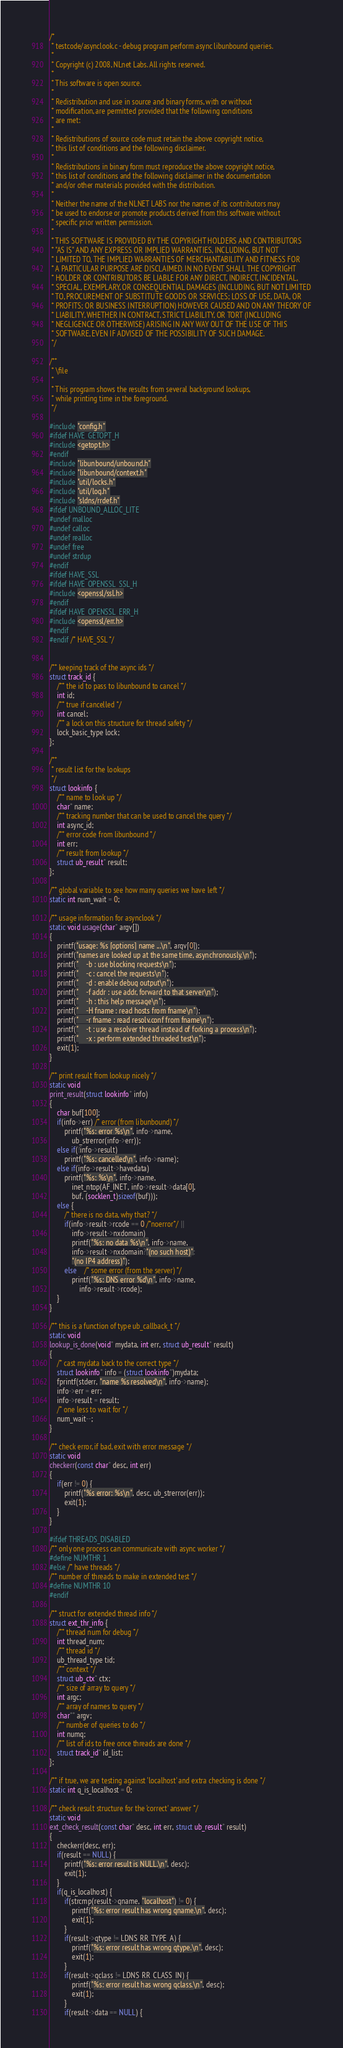<code> <loc_0><loc_0><loc_500><loc_500><_C_>/*
 * testcode/asynclook.c - debug program perform async libunbound queries.
 *
 * Copyright (c) 2008, NLnet Labs. All rights reserved.
 *
 * This software is open source.
 * 
 * Redistribution and use in source and binary forms, with or without
 * modification, are permitted provided that the following conditions
 * are met:
 * 
 * Redistributions of source code must retain the above copyright notice,
 * this list of conditions and the following disclaimer.
 * 
 * Redistributions in binary form must reproduce the above copyright notice,
 * this list of conditions and the following disclaimer in the documentation
 * and/or other materials provided with the distribution.
 * 
 * Neither the name of the NLNET LABS nor the names of its contributors may
 * be used to endorse or promote products derived from this software without
 * specific prior written permission.
 * 
 * THIS SOFTWARE IS PROVIDED BY THE COPYRIGHT HOLDERS AND CONTRIBUTORS
 * "AS IS" AND ANY EXPRESS OR IMPLIED WARRANTIES, INCLUDING, BUT NOT
 * LIMITED TO, THE IMPLIED WARRANTIES OF MERCHANTABILITY AND FITNESS FOR
 * A PARTICULAR PURPOSE ARE DISCLAIMED. IN NO EVENT SHALL THE COPYRIGHT
 * HOLDER OR CONTRIBUTORS BE LIABLE FOR ANY DIRECT, INDIRECT, INCIDENTAL,
 * SPECIAL, EXEMPLARY, OR CONSEQUENTIAL DAMAGES (INCLUDING, BUT NOT LIMITED
 * TO, PROCUREMENT OF SUBSTITUTE GOODS OR SERVICES; LOSS OF USE, DATA, OR
 * PROFITS; OR BUSINESS INTERRUPTION) HOWEVER CAUSED AND ON ANY THEORY OF
 * LIABILITY, WHETHER IN CONTRACT, STRICT LIABILITY, OR TORT (INCLUDING
 * NEGLIGENCE OR OTHERWISE) ARISING IN ANY WAY OUT OF THE USE OF THIS
 * SOFTWARE, EVEN IF ADVISED OF THE POSSIBILITY OF SUCH DAMAGE.
 */

/**
 * \file
 *
 * This program shows the results from several background lookups,
 * while printing time in the foreground.
 */

#include "config.h"
#ifdef HAVE_GETOPT_H
#include <getopt.h>
#endif
#include "libunbound/unbound.h"
#include "libunbound/context.h"
#include "util/locks.h"
#include "util/log.h"
#include "sldns/rrdef.h"
#ifdef UNBOUND_ALLOC_LITE
#undef malloc
#undef calloc
#undef realloc
#undef free
#undef strdup
#endif
#ifdef HAVE_SSL
#ifdef HAVE_OPENSSL_SSL_H
#include <openssl/ssl.h>
#endif
#ifdef HAVE_OPENSSL_ERR_H
#include <openssl/err.h>
#endif
#endif /* HAVE_SSL */


/** keeping track of the async ids */
struct track_id {
	/** the id to pass to libunbound to cancel */
	int id;
	/** true if cancelled */
	int cancel;
	/** a lock on this structure for thread safety */
	lock_basic_type lock;
};

/**
 * result list for the lookups
 */
struct lookinfo {
	/** name to look up */
	char* name;
	/** tracking number that can be used to cancel the query */
	int async_id;
	/** error code from libunbound */
	int err;
	/** result from lookup */
	struct ub_result* result;
};

/** global variable to see how many queries we have left */
static int num_wait = 0;

/** usage information for asynclook */
static void usage(char* argv[])
{
	printf("usage: %s [options] name ...\n", argv[0]);
	printf("names are looked up at the same time, asynchronously.\n");
	printf("	-b : use blocking requests\n");
	printf("	-c : cancel the requests\n");
	printf("	-d : enable debug output\n");
	printf("	-f addr : use addr, forward to that server\n");
	printf("	-h : this help message\n");
	printf("	-H fname : read hosts from fname\n");
	printf("	-r fname : read resolv.conf from fname\n");
	printf("	-t : use a resolver thread instead of forking a process\n");
	printf("	-x : perform extended threaded test\n");
	exit(1);
}

/** print result from lookup nicely */
static void
print_result(struct lookinfo* info)
{
	char buf[100];
	if(info->err) /* error (from libunbound) */
		printf("%s: error %s\n", info->name,
			ub_strerror(info->err));
	else if(!info->result)
		printf("%s: cancelled\n", info->name);
	else if(info->result->havedata)
		printf("%s: %s\n", info->name,
			inet_ntop(AF_INET, info->result->data[0],
			buf, (socklen_t)sizeof(buf)));
	else {
		/* there is no data, why that? */
		if(info->result->rcode == 0 /*noerror*/ ||
			info->result->nxdomain)
			printf("%s: no data %s\n", info->name,
			info->result->nxdomain?"(no such host)":
			"(no IP4 address)");
		else	/* some error (from the server) */
			printf("%s: DNS error %d\n", info->name,
				info->result->rcode);
	}
}

/** this is a function of type ub_callback_t */
static void 
lookup_is_done(void* mydata, int err, struct ub_result* result)
{
	/* cast mydata back to the correct type */
	struct lookinfo* info = (struct lookinfo*)mydata;
	fprintf(stderr, "name %s resolved\n", info->name);
	info->err = err;
	info->result = result;
	/* one less to wait for */
	num_wait--;
}

/** check error, if bad, exit with error message */
static void 
checkerr(const char* desc, int err)
{
	if(err != 0) {
		printf("%s error: %s\n", desc, ub_strerror(err));
		exit(1);
	}
}

#ifdef THREADS_DISABLED
/** only one process can communicate with async worker */
#define NUMTHR 1
#else /* have threads */
/** number of threads to make in extended test */
#define NUMTHR 10
#endif

/** struct for extended thread info */
struct ext_thr_info {
	/** thread num for debug */
	int thread_num;
	/** thread id */
	ub_thread_type tid;
	/** context */
	struct ub_ctx* ctx;
	/** size of array to query */
	int argc;
	/** array of names to query */
	char** argv;
	/** number of queries to do */
	int numq;
	/** list of ids to free once threads are done */
	struct track_id* id_list;
};

/** if true, we are testing against 'localhost' and extra checking is done */
static int q_is_localhost = 0;

/** check result structure for the 'correct' answer */
static void
ext_check_result(const char* desc, int err, struct ub_result* result)
{
	checkerr(desc, err);
	if(result == NULL) {
		printf("%s: error result is NULL.\n", desc);
		exit(1);
	}
	if(q_is_localhost) {
		if(strcmp(result->qname, "localhost") != 0) {
			printf("%s: error result has wrong qname.\n", desc);
			exit(1);
		}
		if(result->qtype != LDNS_RR_TYPE_A) {
			printf("%s: error result has wrong qtype.\n", desc);
			exit(1);
		}
		if(result->qclass != LDNS_RR_CLASS_IN) {
			printf("%s: error result has wrong qclass.\n", desc);
			exit(1);
		}
		if(result->data == NULL) {</code> 